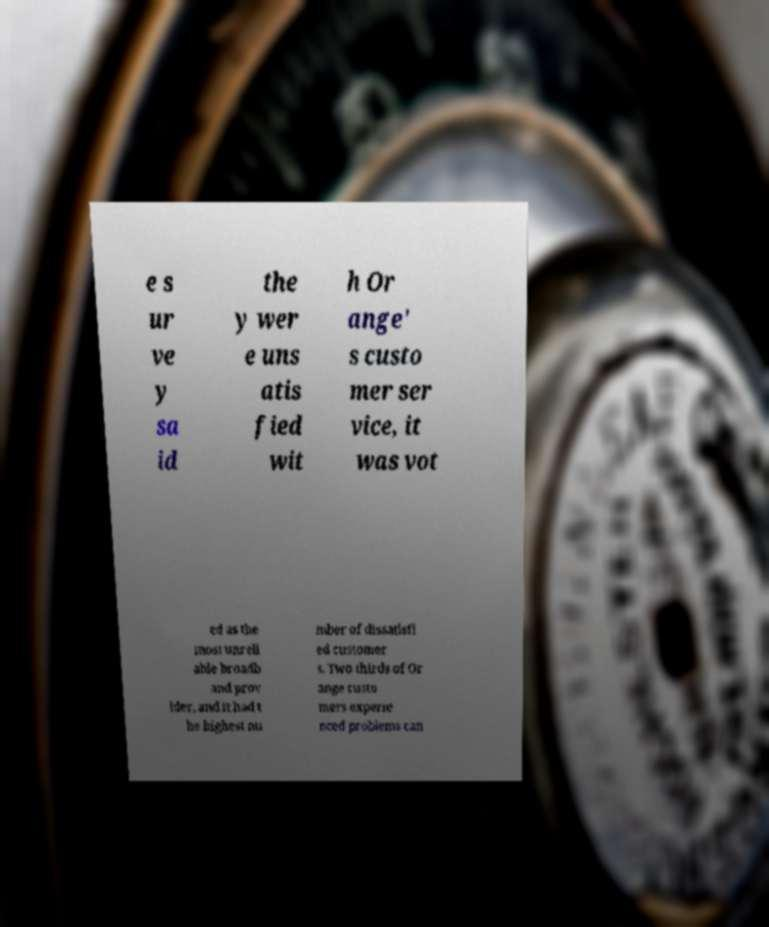Could you extract and type out the text from this image? e s ur ve y sa id the y wer e uns atis fied wit h Or ange' s custo mer ser vice, it was vot ed as the most unreli able broadb and prov ider, and it had t he highest nu mber of dissatisfi ed customer s. Two thirds of Or ange custo mers experie nced problems can 